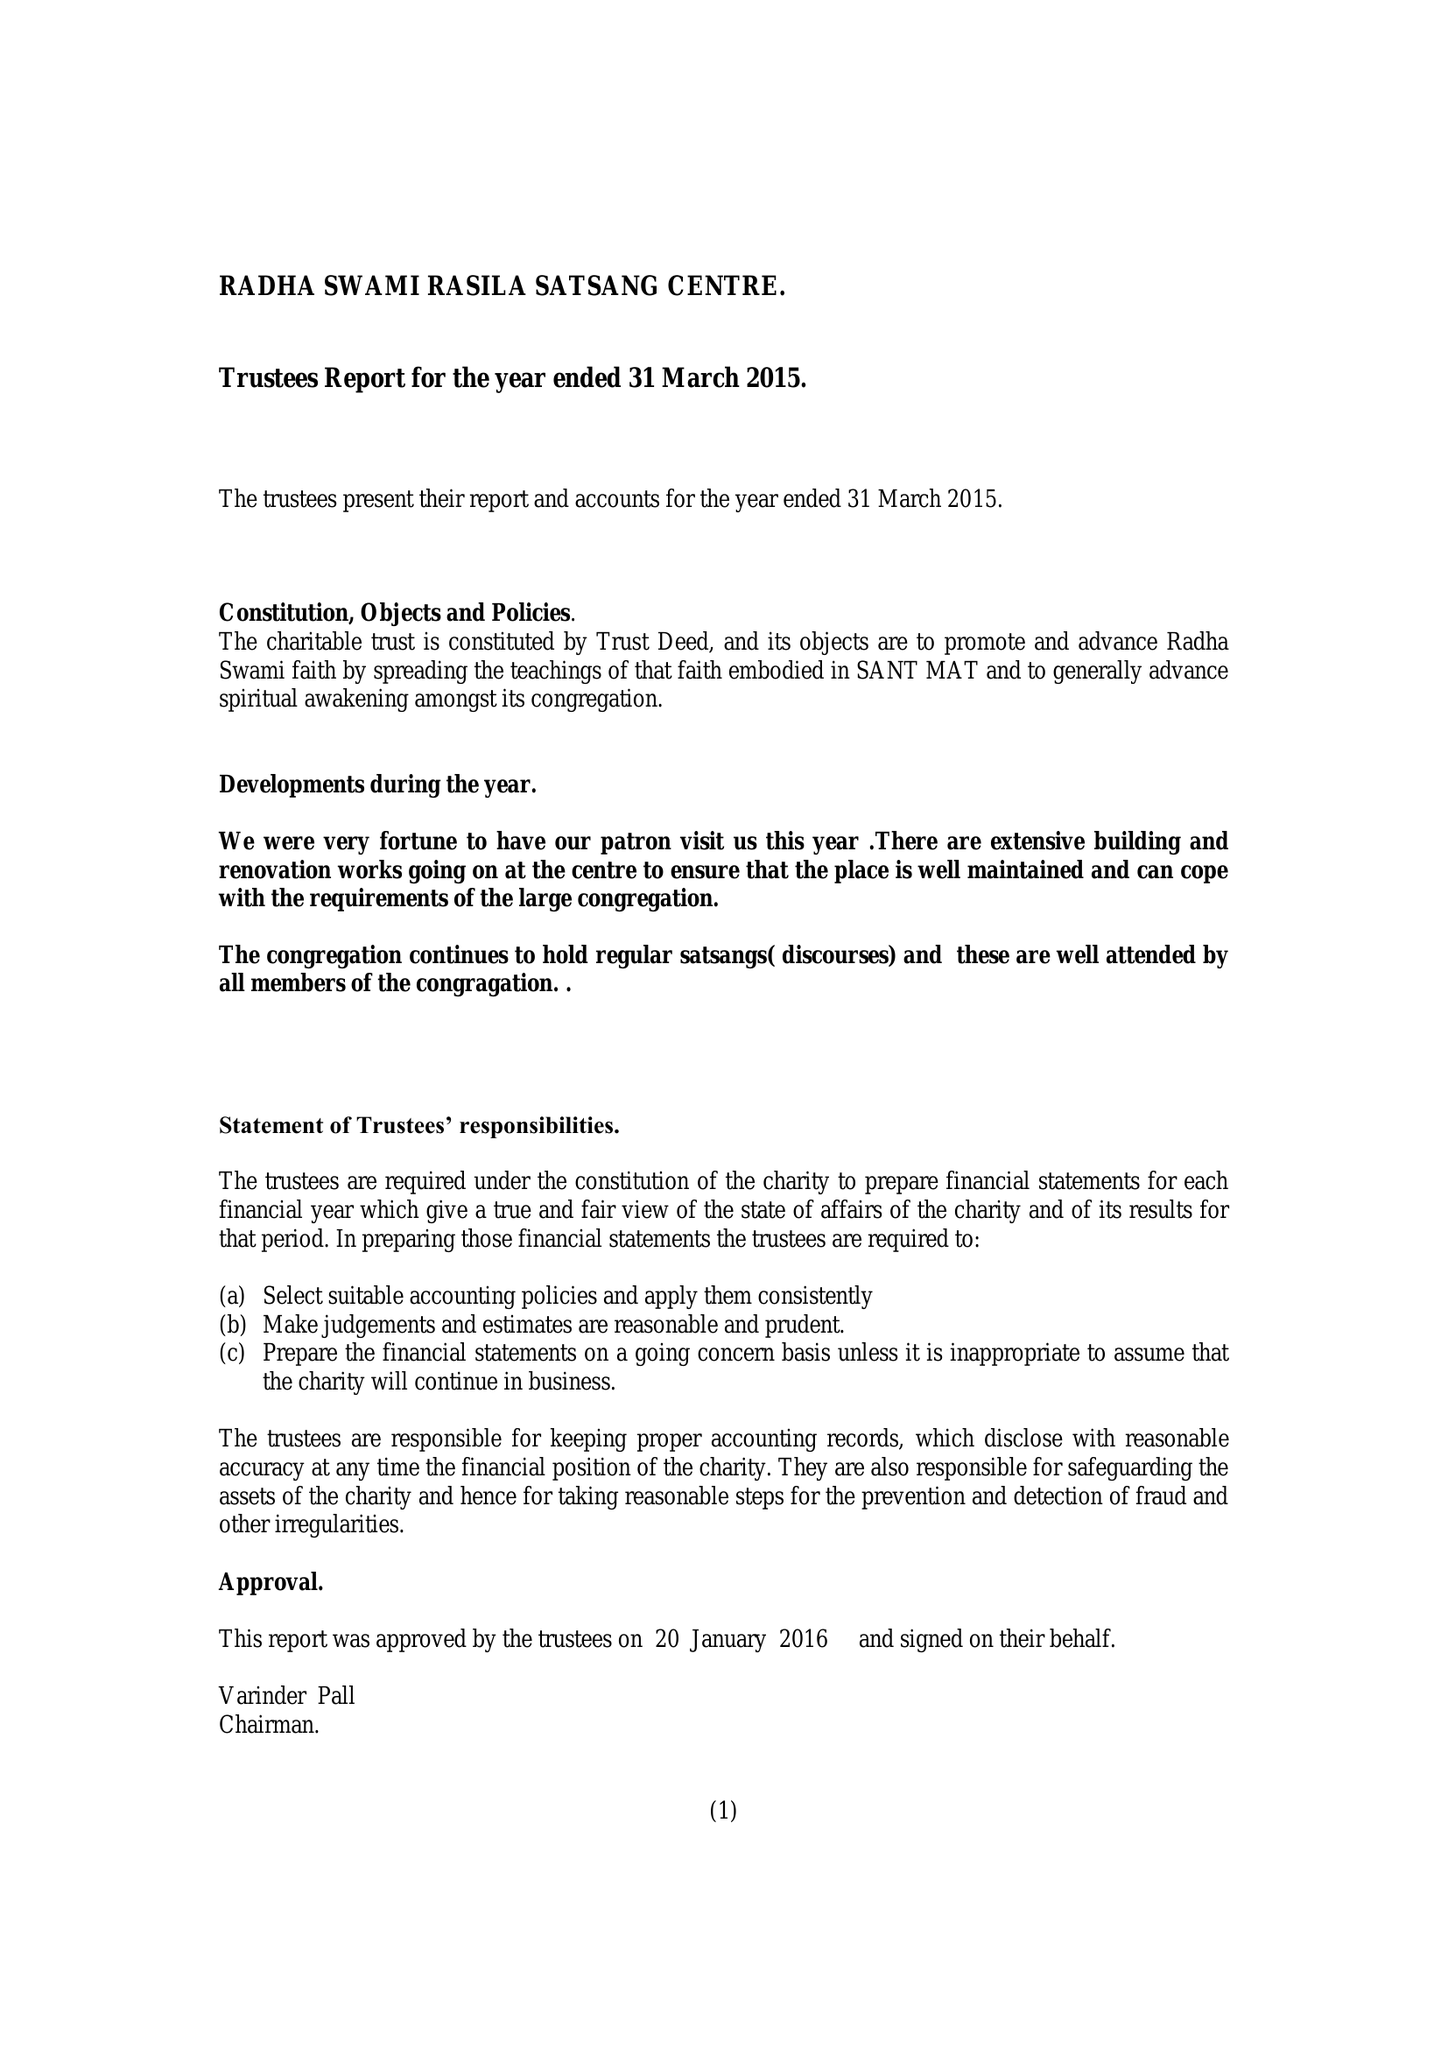What is the value for the income_annually_in_british_pounds?
Answer the question using a single word or phrase. 109240.00 